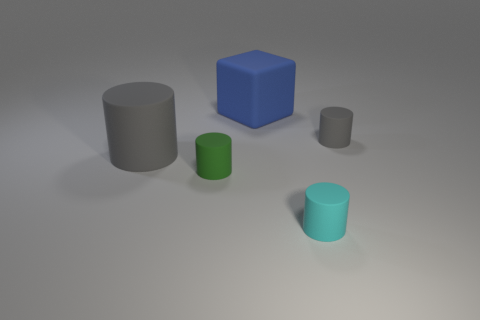What is the material of the other cylinder that is the same color as the big rubber cylinder?
Your response must be concise. Rubber. How many objects are small rubber cylinders in front of the tiny gray cylinder or big red cylinders?
Offer a terse response. 2. What color is the big object that is the same material as the large blue block?
Your answer should be compact. Gray. Is there another matte object of the same size as the cyan thing?
Make the answer very short. Yes. Does the tiny matte cylinder that is to the right of the small cyan object have the same color as the large cube?
Ensure brevity in your answer.  No. What color is the small cylinder that is both behind the cyan thing and to the left of the small gray rubber cylinder?
Your response must be concise. Green. There is a gray object that is the same size as the cyan object; what shape is it?
Keep it short and to the point. Cylinder. Are there any tiny gray things that have the same shape as the big gray rubber object?
Keep it short and to the point. Yes. Is the size of the thing that is in front of the green cylinder the same as the tiny gray matte cylinder?
Provide a short and direct response. Yes. What size is the cylinder that is both behind the tiny green object and on the left side of the big matte block?
Give a very brief answer. Large. 